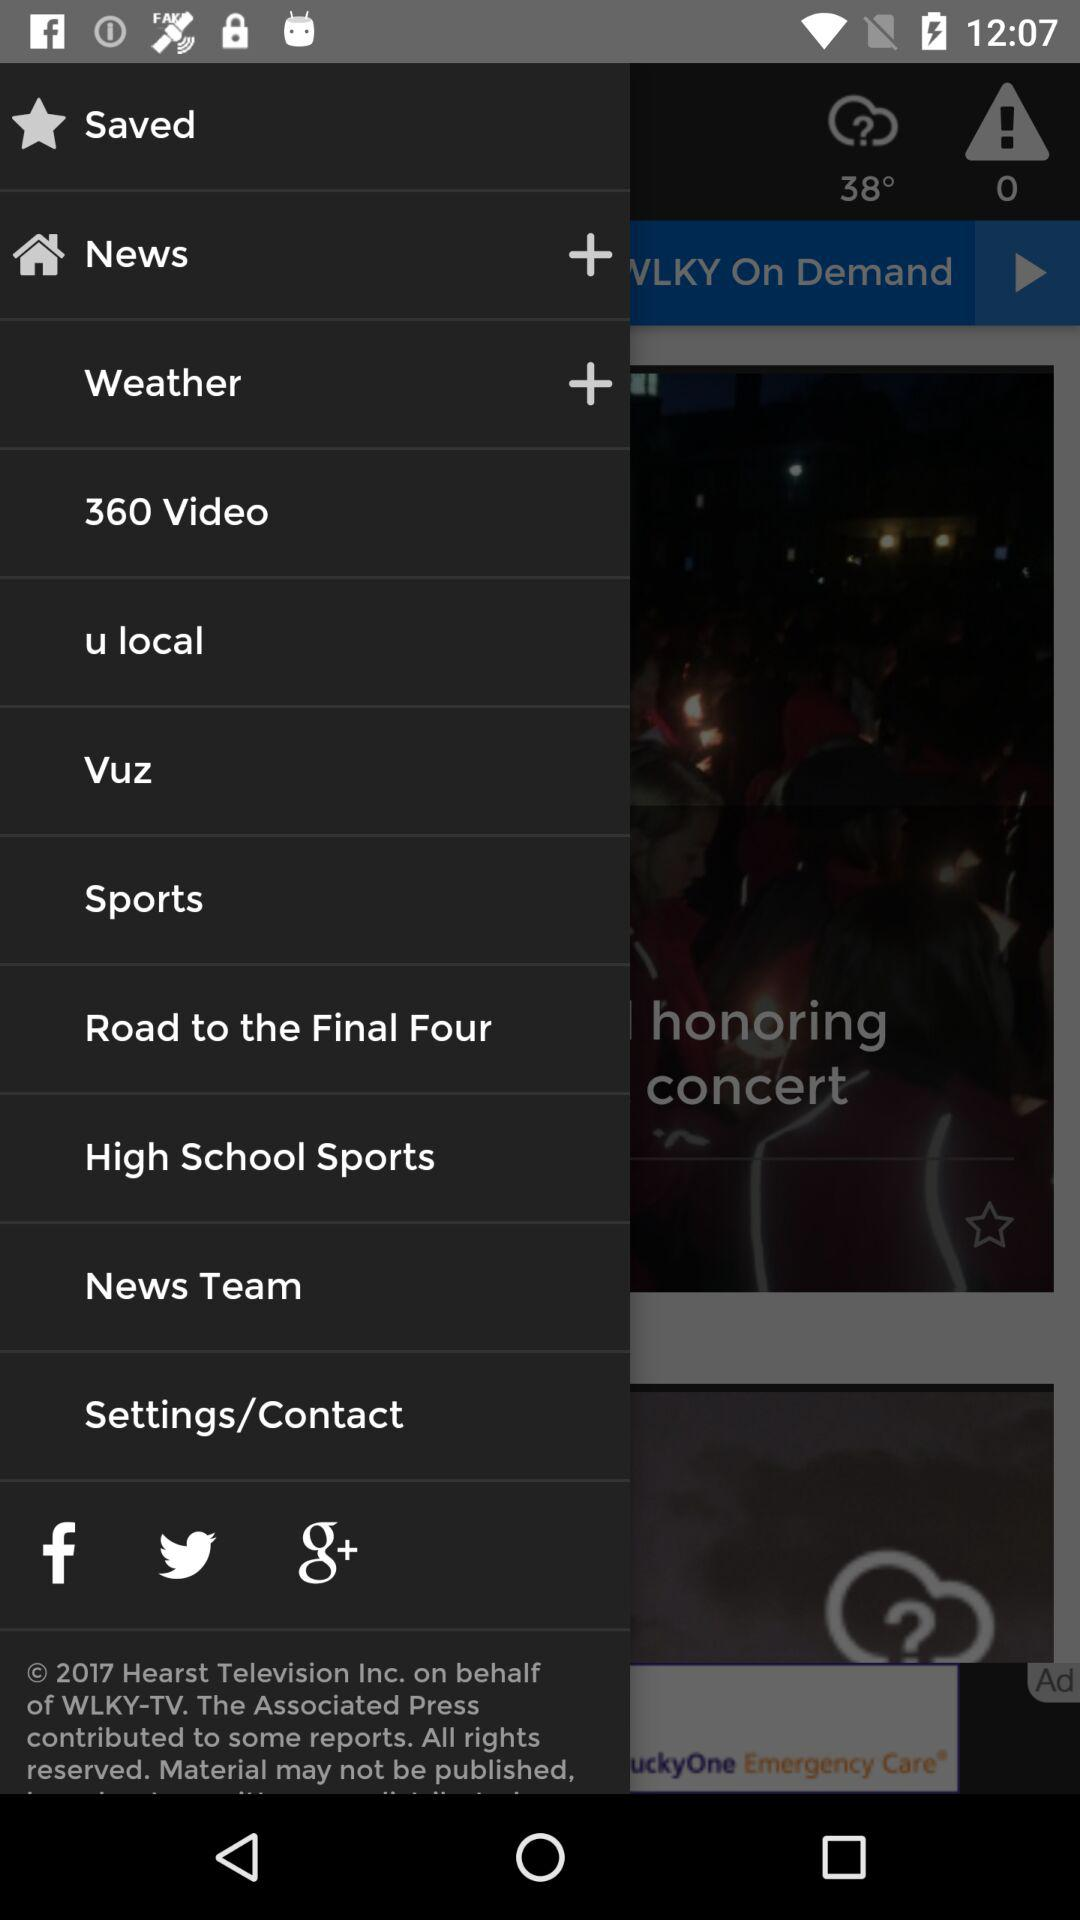What other social media platforms are there? Other social media platforms are "Facebook", "Twitter" and "Google+". 